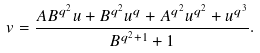<formula> <loc_0><loc_0><loc_500><loc_500>v = \frac { A B ^ { q ^ { 2 } } u + B ^ { q ^ { 2 } } u ^ { q } + A ^ { q ^ { 2 } } u ^ { q ^ { 2 } } + u ^ { q ^ { 3 } } } { B ^ { q ^ { 2 } + 1 } + 1 } .</formula> 